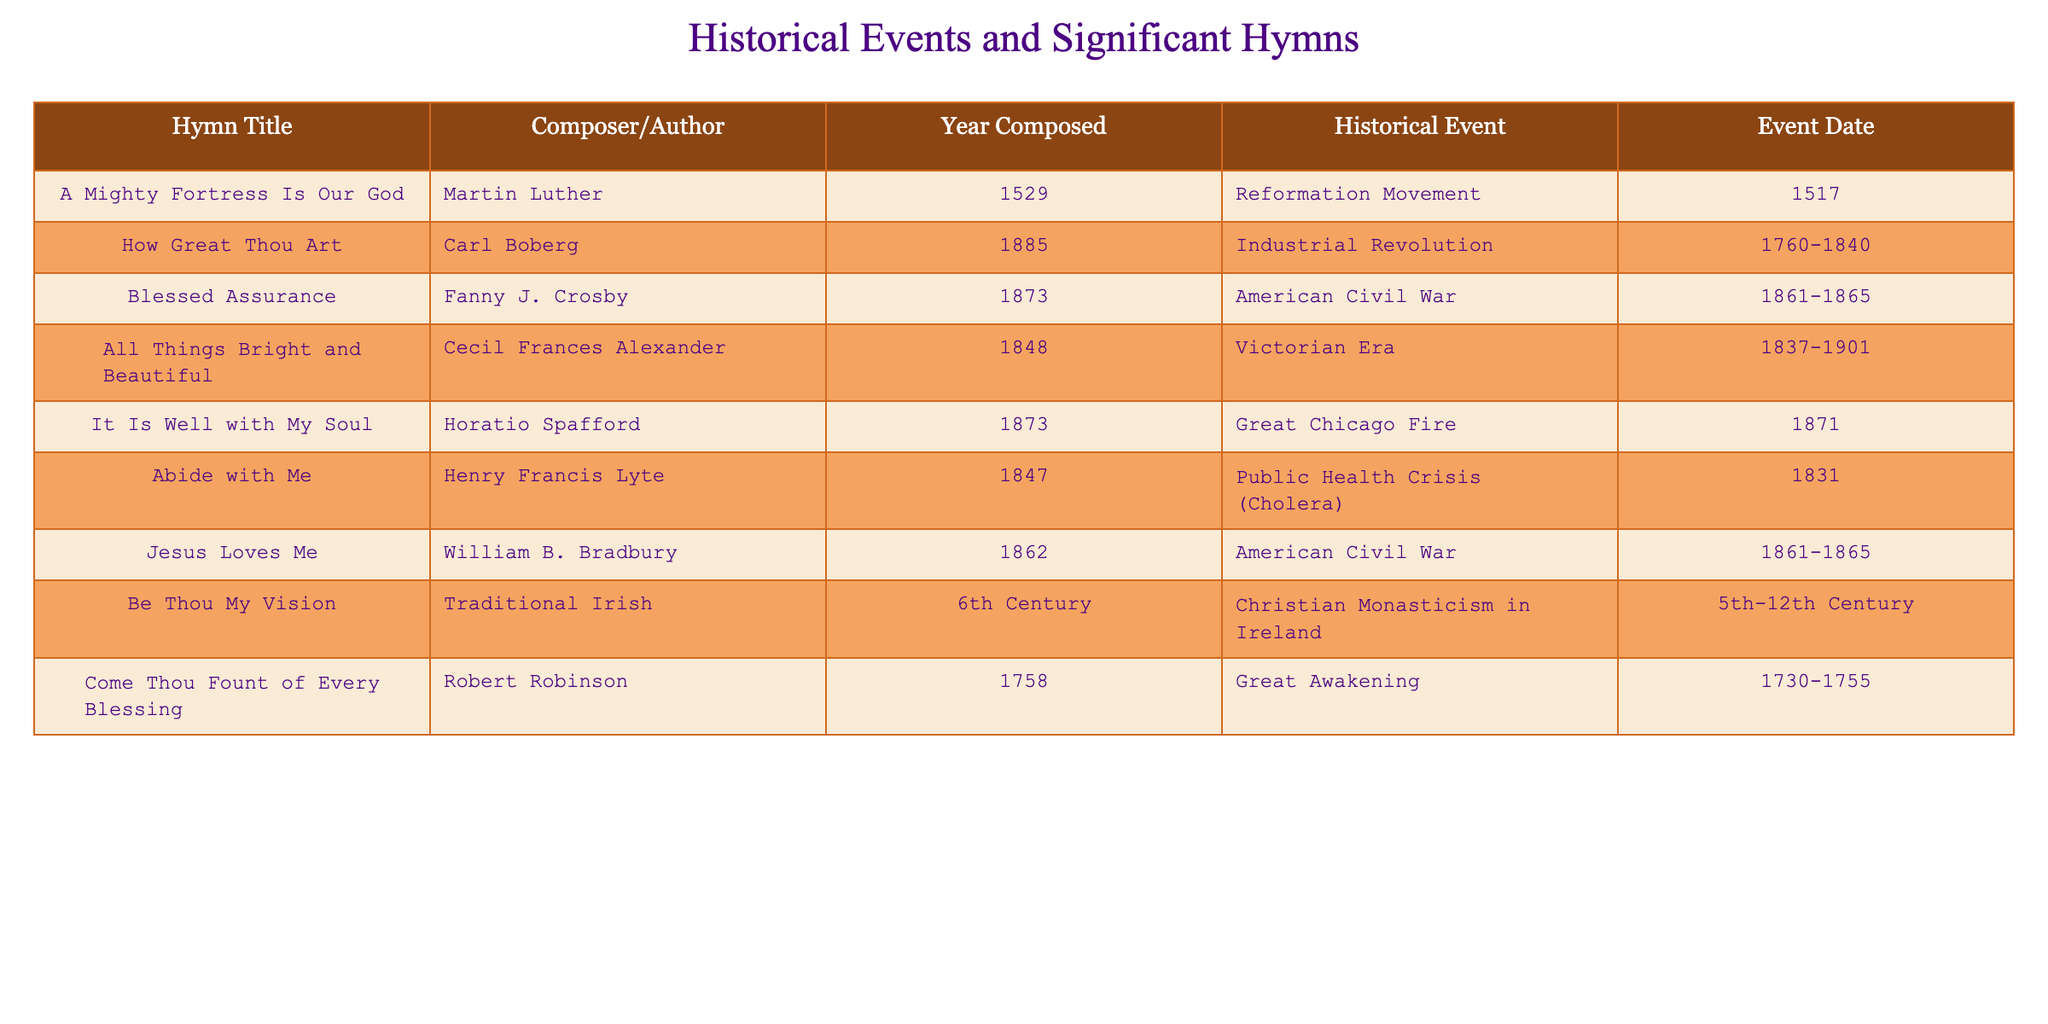What is the title of the hymn composed by Martin Luther? The table lists "A Mighty Fortress Is Our God" as the hymn composed by Martin Luther in 1529.
Answer: "A Mighty Fortress Is Our God" How many hymns were composed during the American Civil War? The table shows two hymns related to the American Civil War: "Blessed Assurance" and "Jesus Loves Me." Therefore, the total is two.
Answer: 2 Which historical event correlates with "How Great Thou Art"? The table states that "How Great Thou Art," composed in 1885, correlates with the Industrial Revolution, which took place from 1760 to 1840.
Answer: Industrial Revolution Is there a hymn that was composed before the 18th century? The table lists "Be Thou My Vision," composed in the 6th Century, which is before the 18th century. Therefore, the answer is yes.
Answer: Yes What is the historical event linked to "Come Thou Fount of Every Blessing"? According to the table, "Come Thou Fount of Every Blessing," composed in 1758, is linked to the Great Awakening.
Answer: Great Awakening Which hymn was composed in the same year as the Great Chicago Fire? The table indicates that "It Is Well with My Soul" was composed in 1873, the same year as the Great Chicago Fire occurred.
Answer: "It Is Well with My Soul" Count the number of hymns composed in the Victorian Era and indicate their titles. The table shows "All Things Bright and Beautiful" was composed in 1848 during the Victorian Era. Only one hymn correlates with this period.
Answer: 1 hymn: "All Things Bright and Beautiful" Which composer is associated with the hymn "Abide with Me", and what major public health event does it relate to? "Abide with Me" was composed by Henry Francis Lyte and it relates to the cholera outbreak in 1831, as indicated in the table.
Answer: Henry Francis Lyte; Cholera outbreak How many hymns are associated with health crises? The table shows one hymn associated with a health crisis, which is "Abide with Me," linked to the cholera in 1831.
Answer: 1 Identify two historical events that occurred in the 19th century and their corresponding hymns. From the table, the two historical events in the 19th century are the American Civil War and the Industrial Revolution, with corresponding hymns "Blessed Assurance" and "How Great Thou Art."
Answer: American Civil War: "Blessed Assurance"; Industrial Revolution: "How Great Thou Art" 